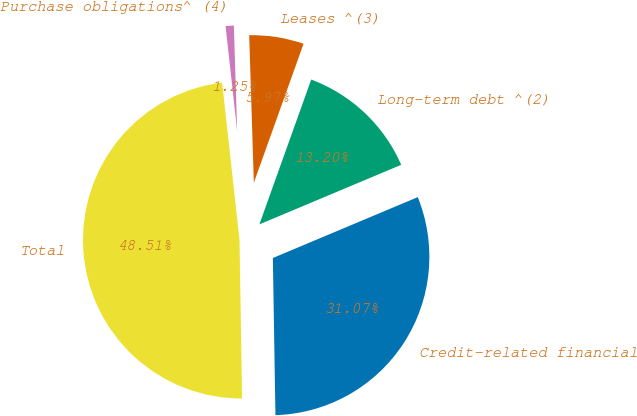Convert chart. <chart><loc_0><loc_0><loc_500><loc_500><pie_chart><fcel>Credit-related financial<fcel>Long-term debt ^(2)<fcel>Leases ^(3)<fcel>Purchase obligations^ (4)<fcel>Total<nl><fcel>31.07%<fcel>13.2%<fcel>5.97%<fcel>1.25%<fcel>48.51%<nl></chart> 